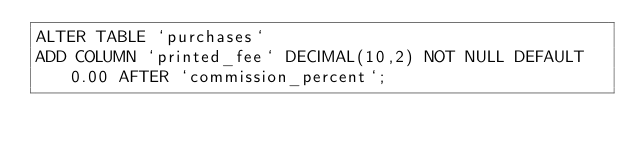<code> <loc_0><loc_0><loc_500><loc_500><_SQL_>ALTER TABLE `purchases` 
ADD COLUMN `printed_fee` DECIMAL(10,2) NOT NULL DEFAULT 0.00 AFTER `commission_percent`;
</code> 